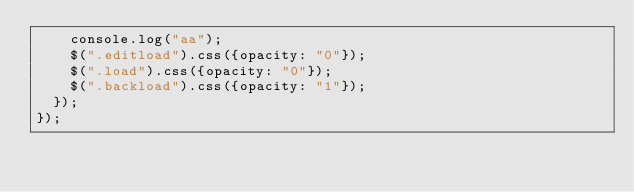Convert code to text. <code><loc_0><loc_0><loc_500><loc_500><_JavaScript_>	  console.log("aa");
	  $(".editload").css({opacity: "0"});
	  $(".load").css({opacity: "0"});
	  $(".backload").css({opacity: "1"});
  });
});</code> 